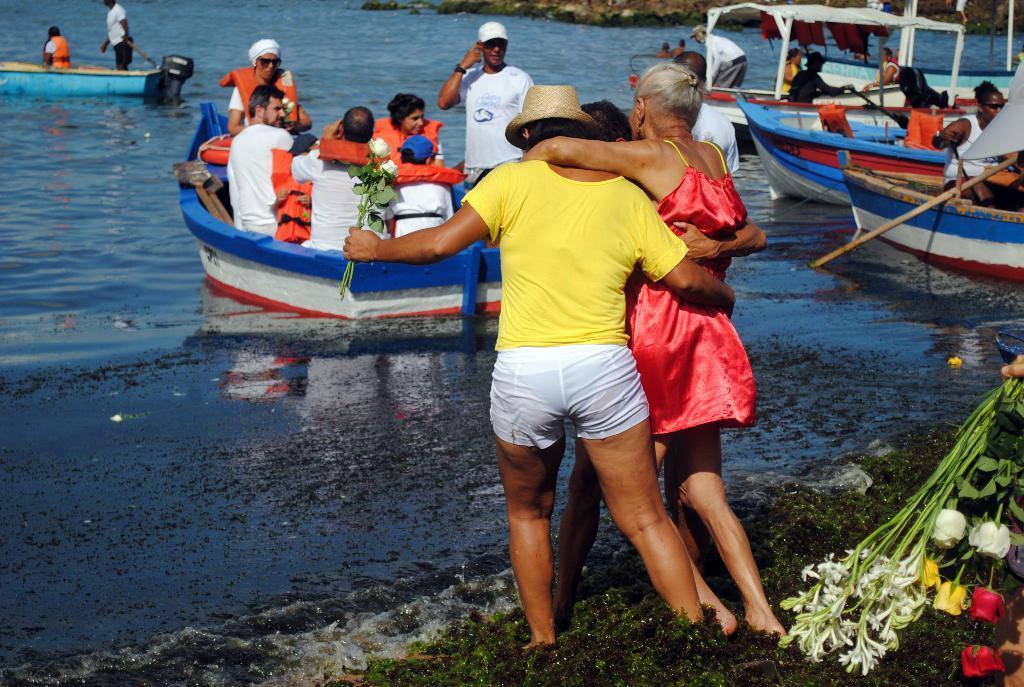In one or two sentences, can you explain what this image depicts? In this picture I can see a person's hand on the right, who is holding flowers and I see 3 persons who are standing in front. In the background I can see the water on which there are few boats and I see people on the boats. 